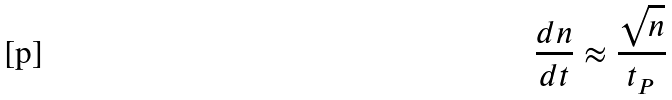Convert formula to latex. <formula><loc_0><loc_0><loc_500><loc_500>\frac { d n } { d t } \approx \frac { \sqrt { n } } { t _ { P } }</formula> 